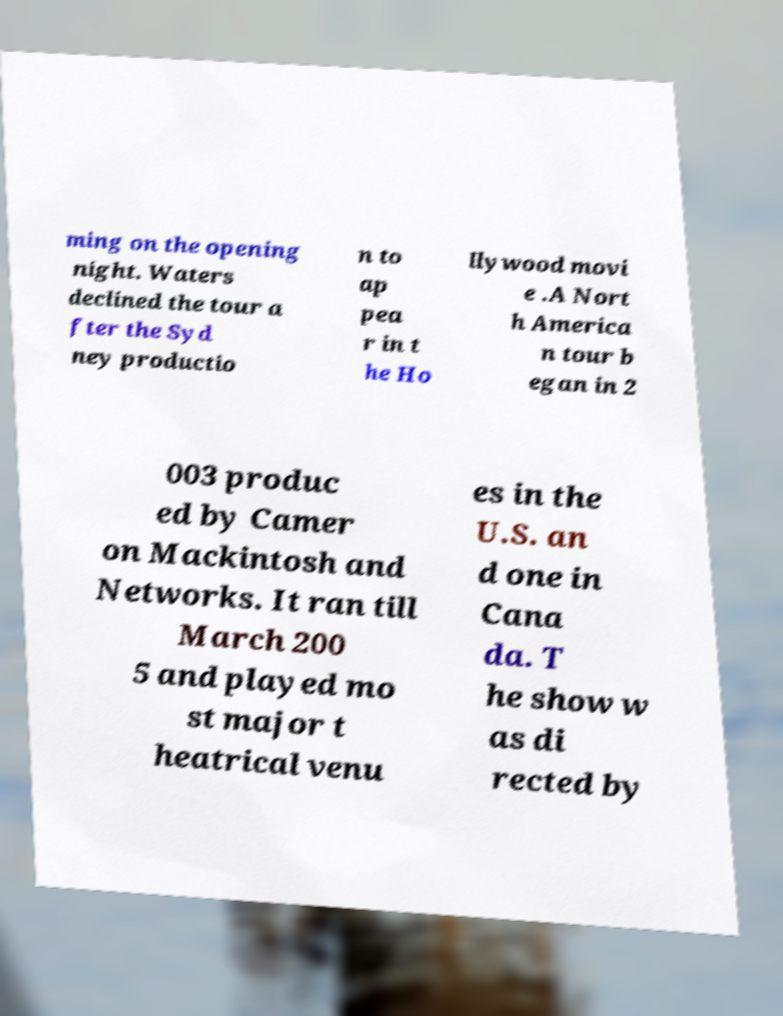For documentation purposes, I need the text within this image transcribed. Could you provide that? ming on the opening night. Waters declined the tour a fter the Syd ney productio n to ap pea r in t he Ho llywood movi e .A Nort h America n tour b egan in 2 003 produc ed by Camer on Mackintosh and Networks. It ran till March 200 5 and played mo st major t heatrical venu es in the U.S. an d one in Cana da. T he show w as di rected by 